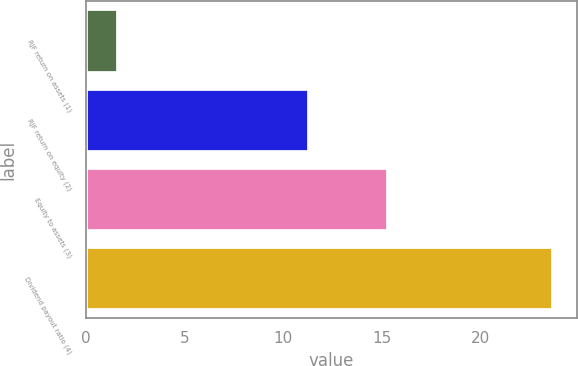<chart> <loc_0><loc_0><loc_500><loc_500><bar_chart><fcel>RJF return on assets (1)<fcel>RJF return on equity (2)<fcel>Equity to assets (3)<fcel>Dividend payout ratio (4)<nl><fcel>1.6<fcel>11.3<fcel>15.3<fcel>23.7<nl></chart> 